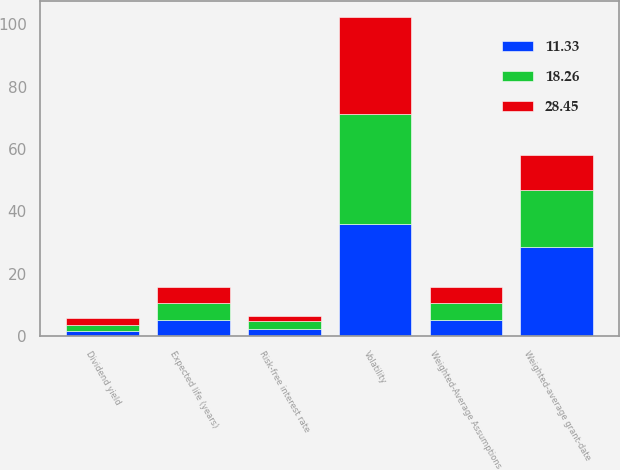<chart> <loc_0><loc_0><loc_500><loc_500><stacked_bar_chart><ecel><fcel>Weighted-Average Assumptions<fcel>Risk-free interest rate<fcel>Dividend yield<fcel>Expected life (years)<fcel>Volatility<fcel>Weighted-average grant-date<nl><fcel>11.33<fcel>5.3<fcel>2.3<fcel>1.6<fcel>5.3<fcel>35.9<fcel>28.45<nl><fcel>18.26<fcel>5.3<fcel>2.4<fcel>1.8<fcel>5.4<fcel>35.2<fcel>18.26<nl><fcel>28.45<fcel>5.3<fcel>1.9<fcel>2.3<fcel>5.1<fcel>31.3<fcel>11.33<nl></chart> 